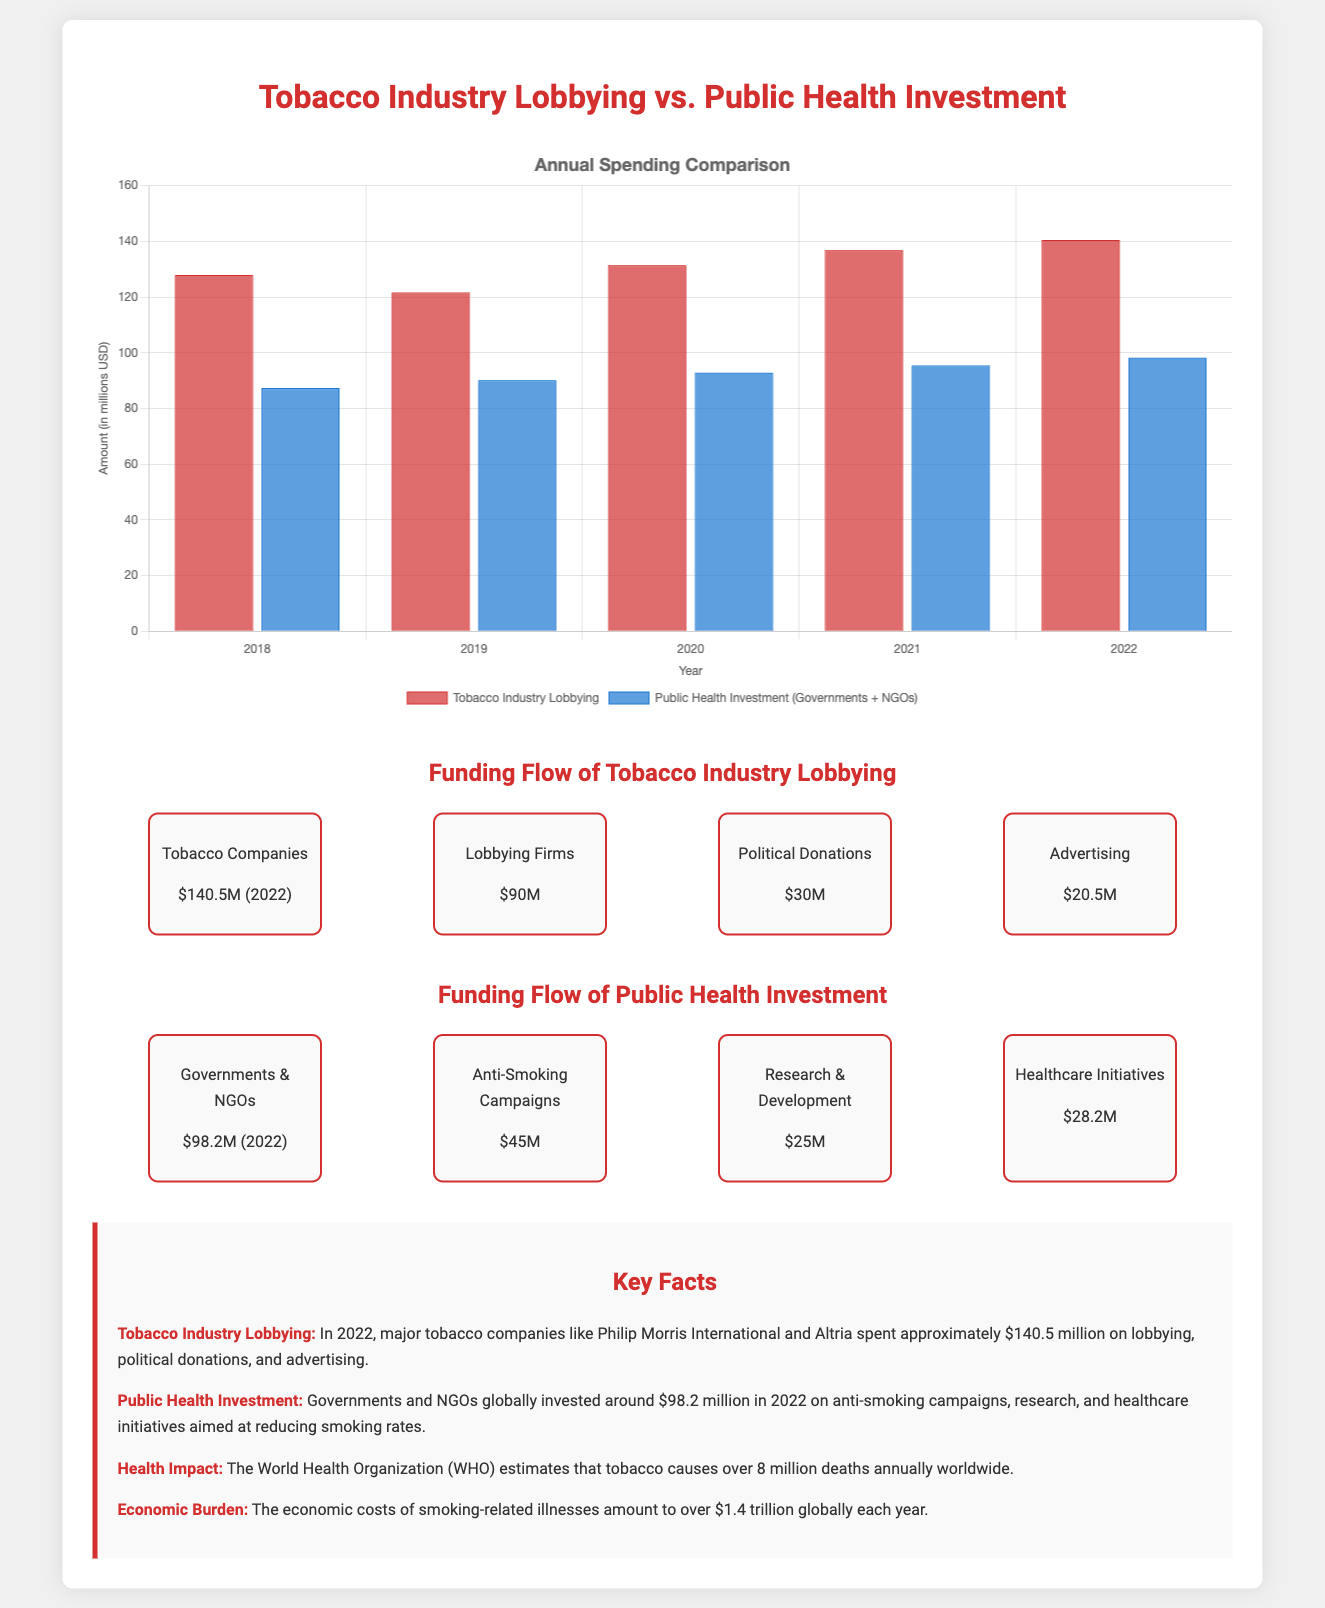What was the total amount spent by tobacco companies on lobbying in 2022? The amount spent by tobacco companies on lobbying in 2022 was $140.5 million, as stated in the flow diagram.
Answer: $140.5 million How much did governments and NGOs invest in public health initiatives in 2022? The total investment by governments and NGOs in public health initiatives in 2022 was $98.2 million, according to the flow diagram.
Answer: $98.2 million What was the amount allocated to anti-smoking campaigns by governments and NGOs? The investment in anti-smoking campaigns by governments and NGOs was $45 million, as indicated in the funding flow diagram.
Answer: $45 million Which organization estimates that tobacco causes over 8 million deaths annually? The World Health Organization (WHO) is the organization that estimates this, as mentioned in the facts section.
Answer: World Health Organization (WHO) What is the economic cost of smoking-related illnesses globally each year? The economic costs of smoking-related illnesses amount to over $1.4 trillion globally each year, as per the facts provided.
Answer: Over $1.4 trillion What type of diagram is used to illustrate the funding flow of the tobacco industry? A flow diagram is used to illustrate the funding flow of the tobacco industry, as seen in the document.
Answer: Flow diagram How does the spending on tobacco industry lobbying compare to public health investment in the bar chart? The bar chart compares annual spending between tobacco industry lobbying and public health investment, showing that tobacco lobbying is higher.
Answer: Tobacco lobbying is higher 